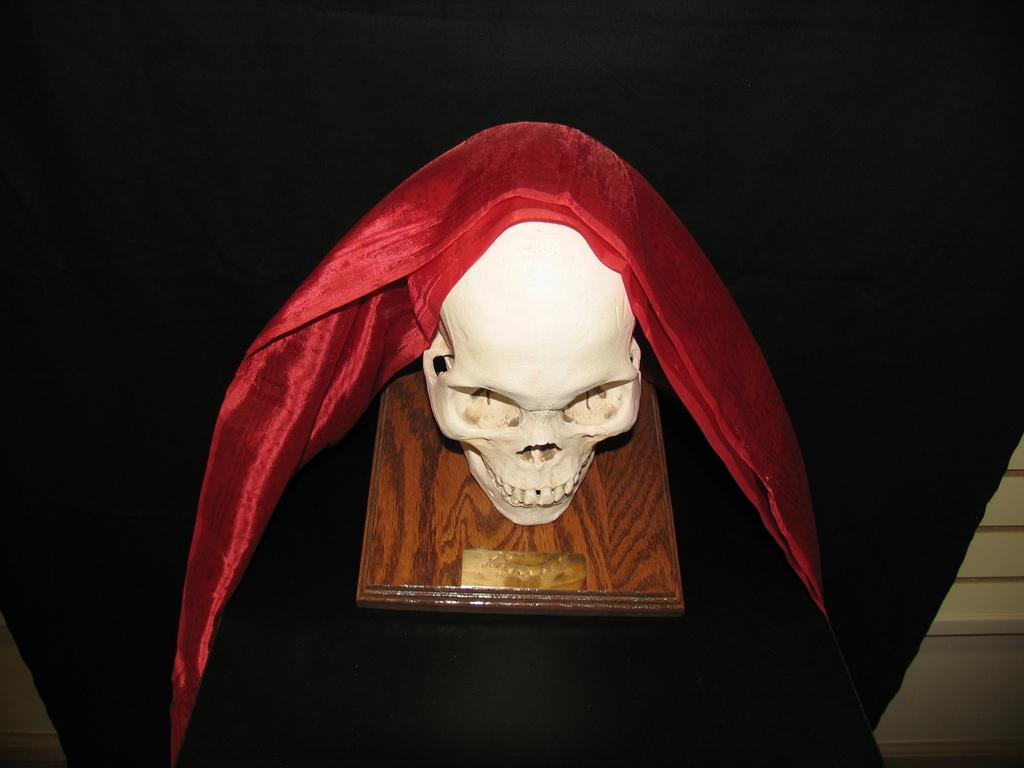What is the main object in the image? There is a skull in the image. What is the skull placed on? The skull is placed on a wooden board. What colors of cloth are present in the image? There is a red color cloth on the skull and a black color cloth at the bottom of the image. How much profit can be made from the skull in the image? There is no indication of profit or any financial aspect related to the skull in the image. 